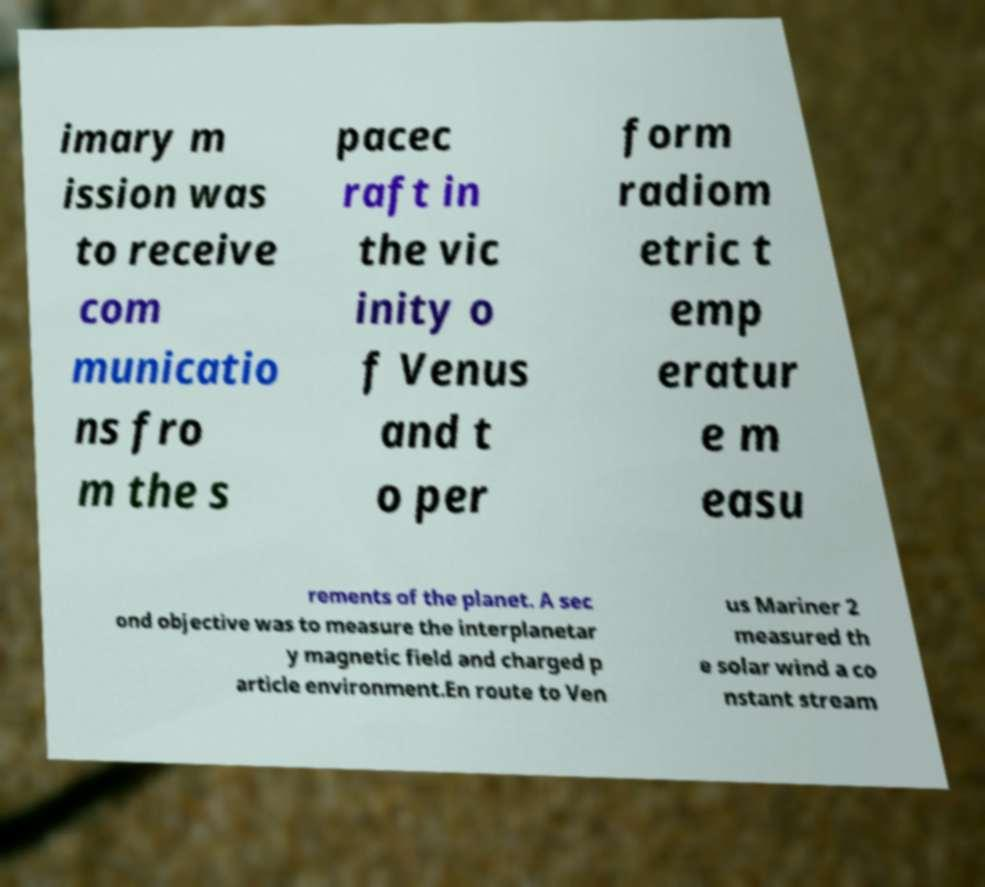Can you accurately transcribe the text from the provided image for me? imary m ission was to receive com municatio ns fro m the s pacec raft in the vic inity o f Venus and t o per form radiom etric t emp eratur e m easu rements of the planet. A sec ond objective was to measure the interplanetar y magnetic field and charged p article environment.En route to Ven us Mariner 2 measured th e solar wind a co nstant stream 